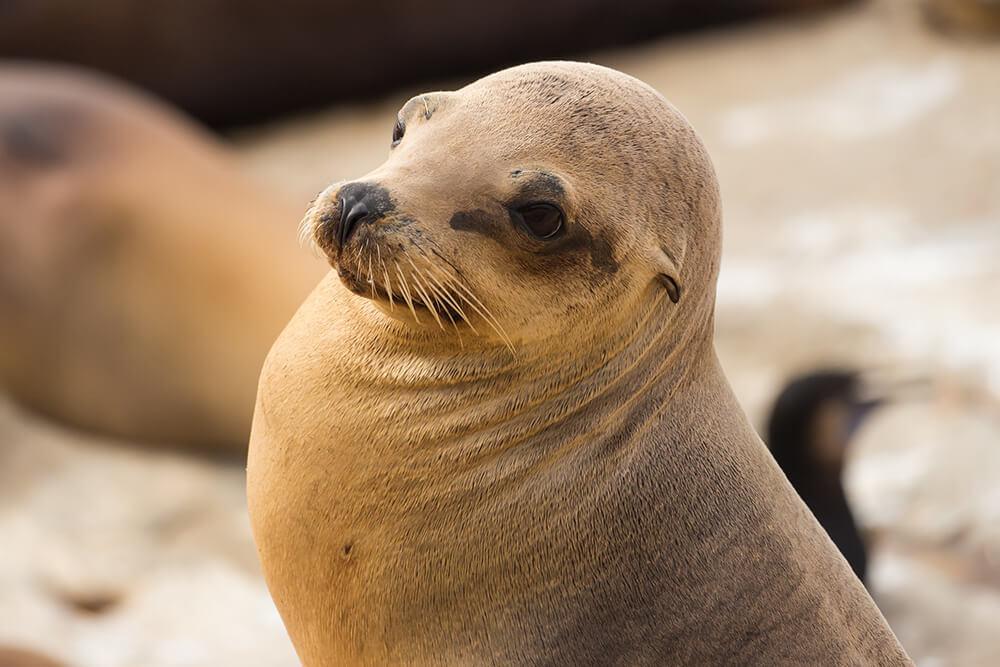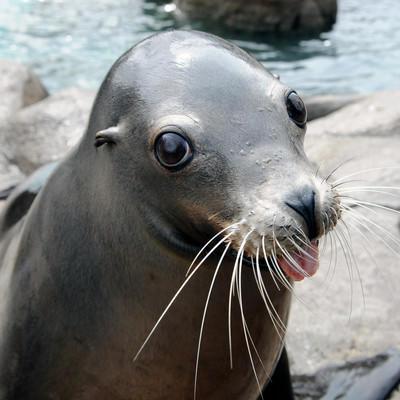The first image is the image on the left, the second image is the image on the right. Examine the images to the left and right. Is the description "The left image depicts a young seal which is not black." accurate? Answer yes or no. Yes. 